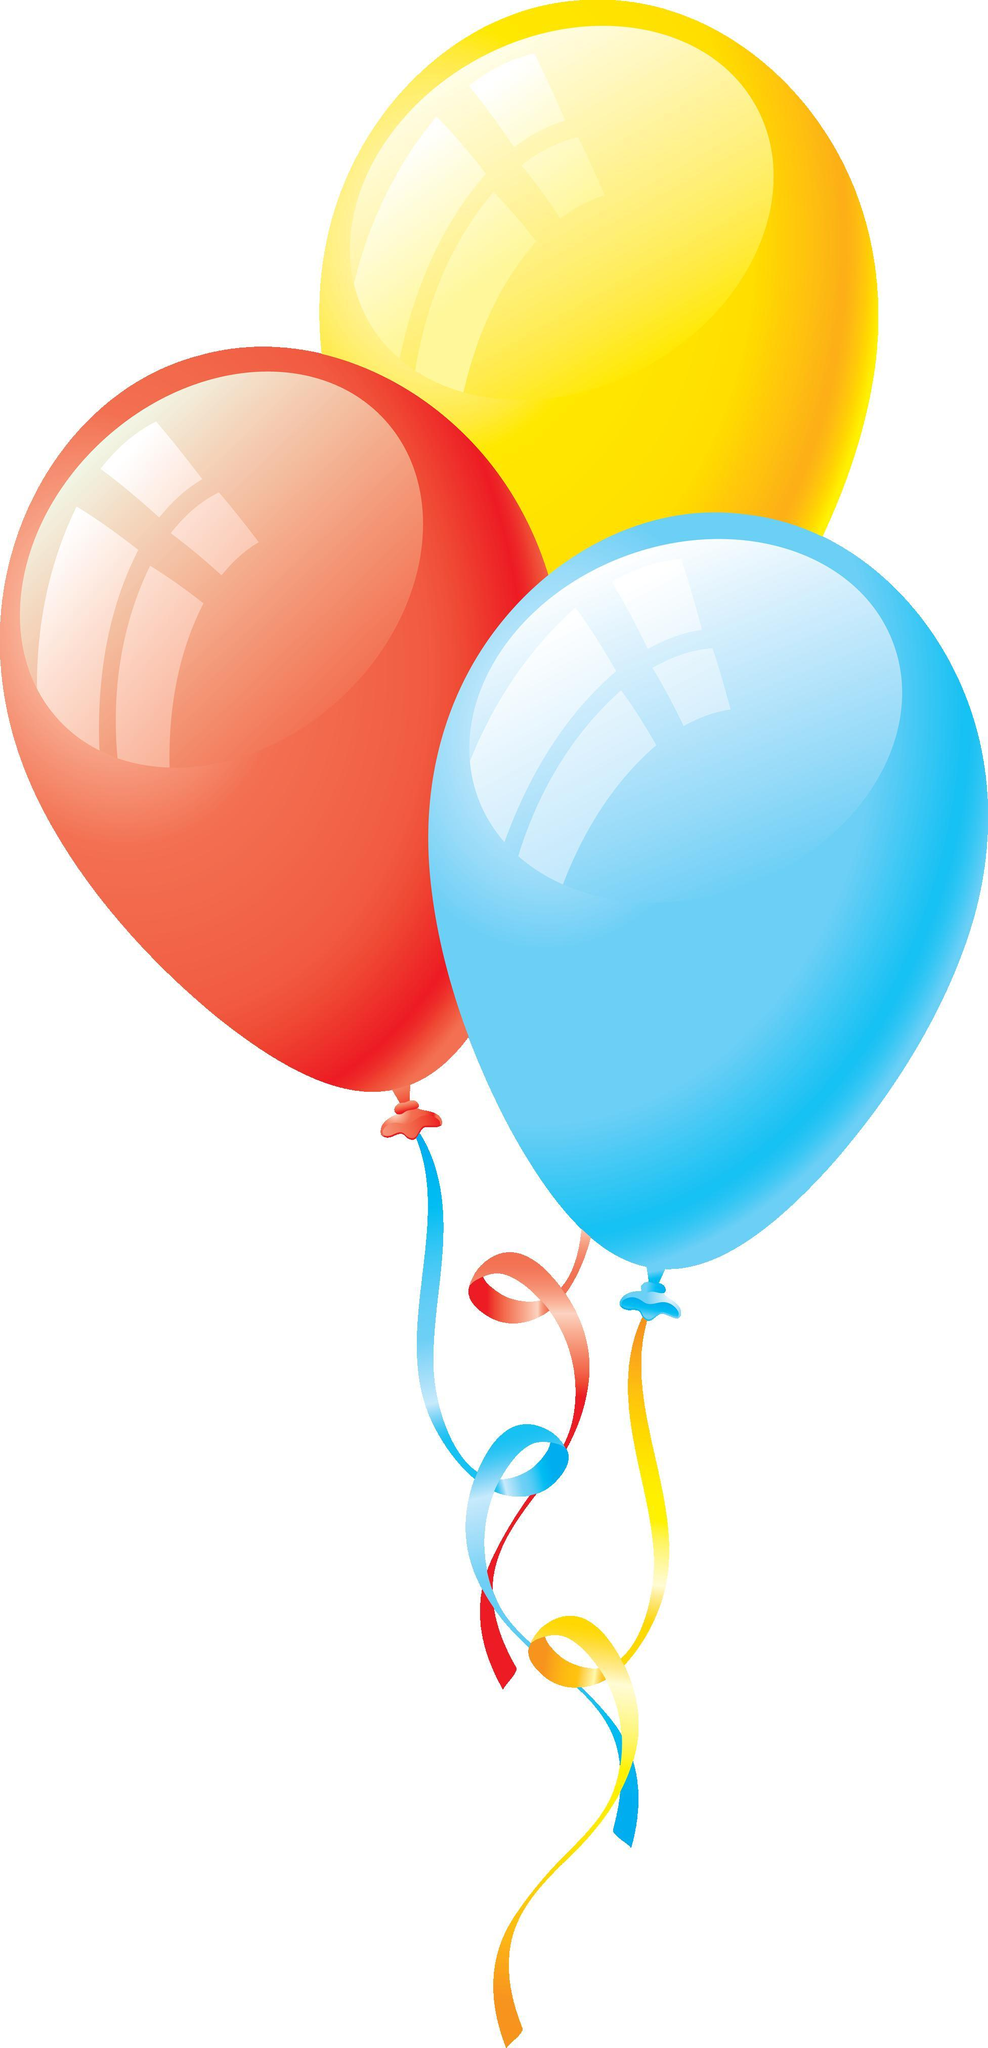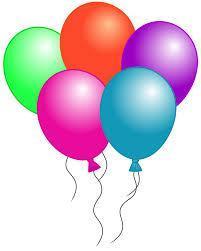The first image is the image on the left, the second image is the image on the right. For the images displayed, is the sentence "An image shows exactly three overlapping balloons, and one of the balloons is yellow." factually correct? Answer yes or no. Yes. The first image is the image on the left, the second image is the image on the right. Examine the images to the left and right. Is the description "In one image, there is one blue balloon, one yellow balloon, and one purple balloon side by side" accurate? Answer yes or no. No. 